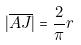<formula> <loc_0><loc_0><loc_500><loc_500>| \overline { A J } | = \frac { 2 } { \pi } r</formula> 